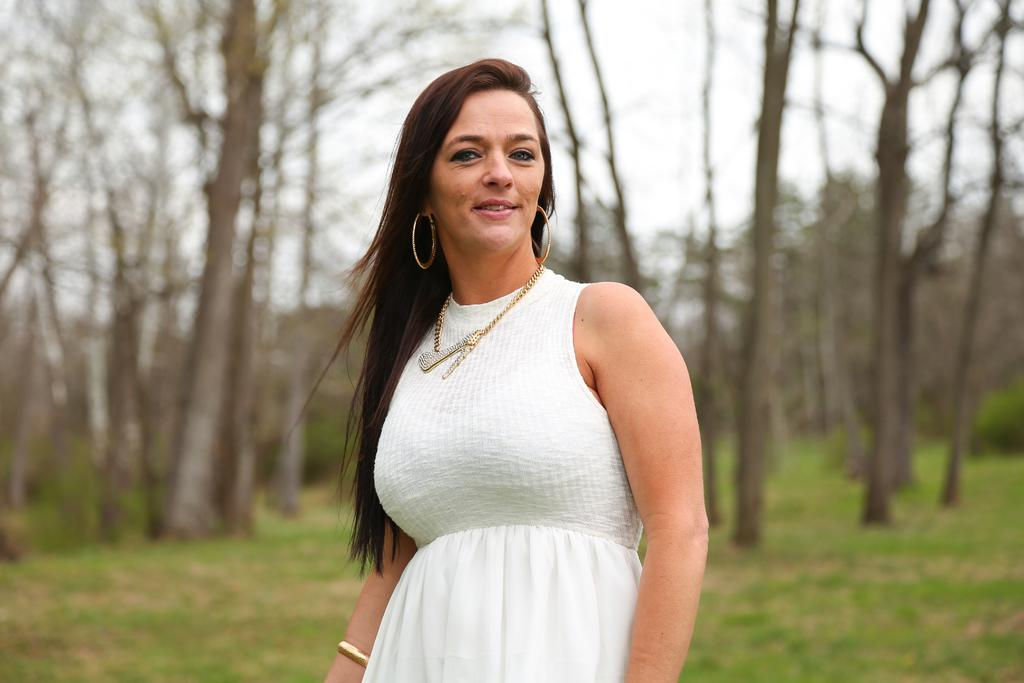Who is present in the image? There is a woman in the image. What is the woman wearing? The woman is wearing a white dress. Where is the woman standing? The woman is standing on the ground. What type of vegetation can be seen in the image? There are trees and bushes in the image. What is the color of the grass in the image? The grass on the ground is green. What is visible at the top of the image? The sky is visible at the top of the image. What type of cabbage is the woman holding in the image? There is no cabbage present in the image. How many legs does the woman have in the image? The woman has two legs in the image. 